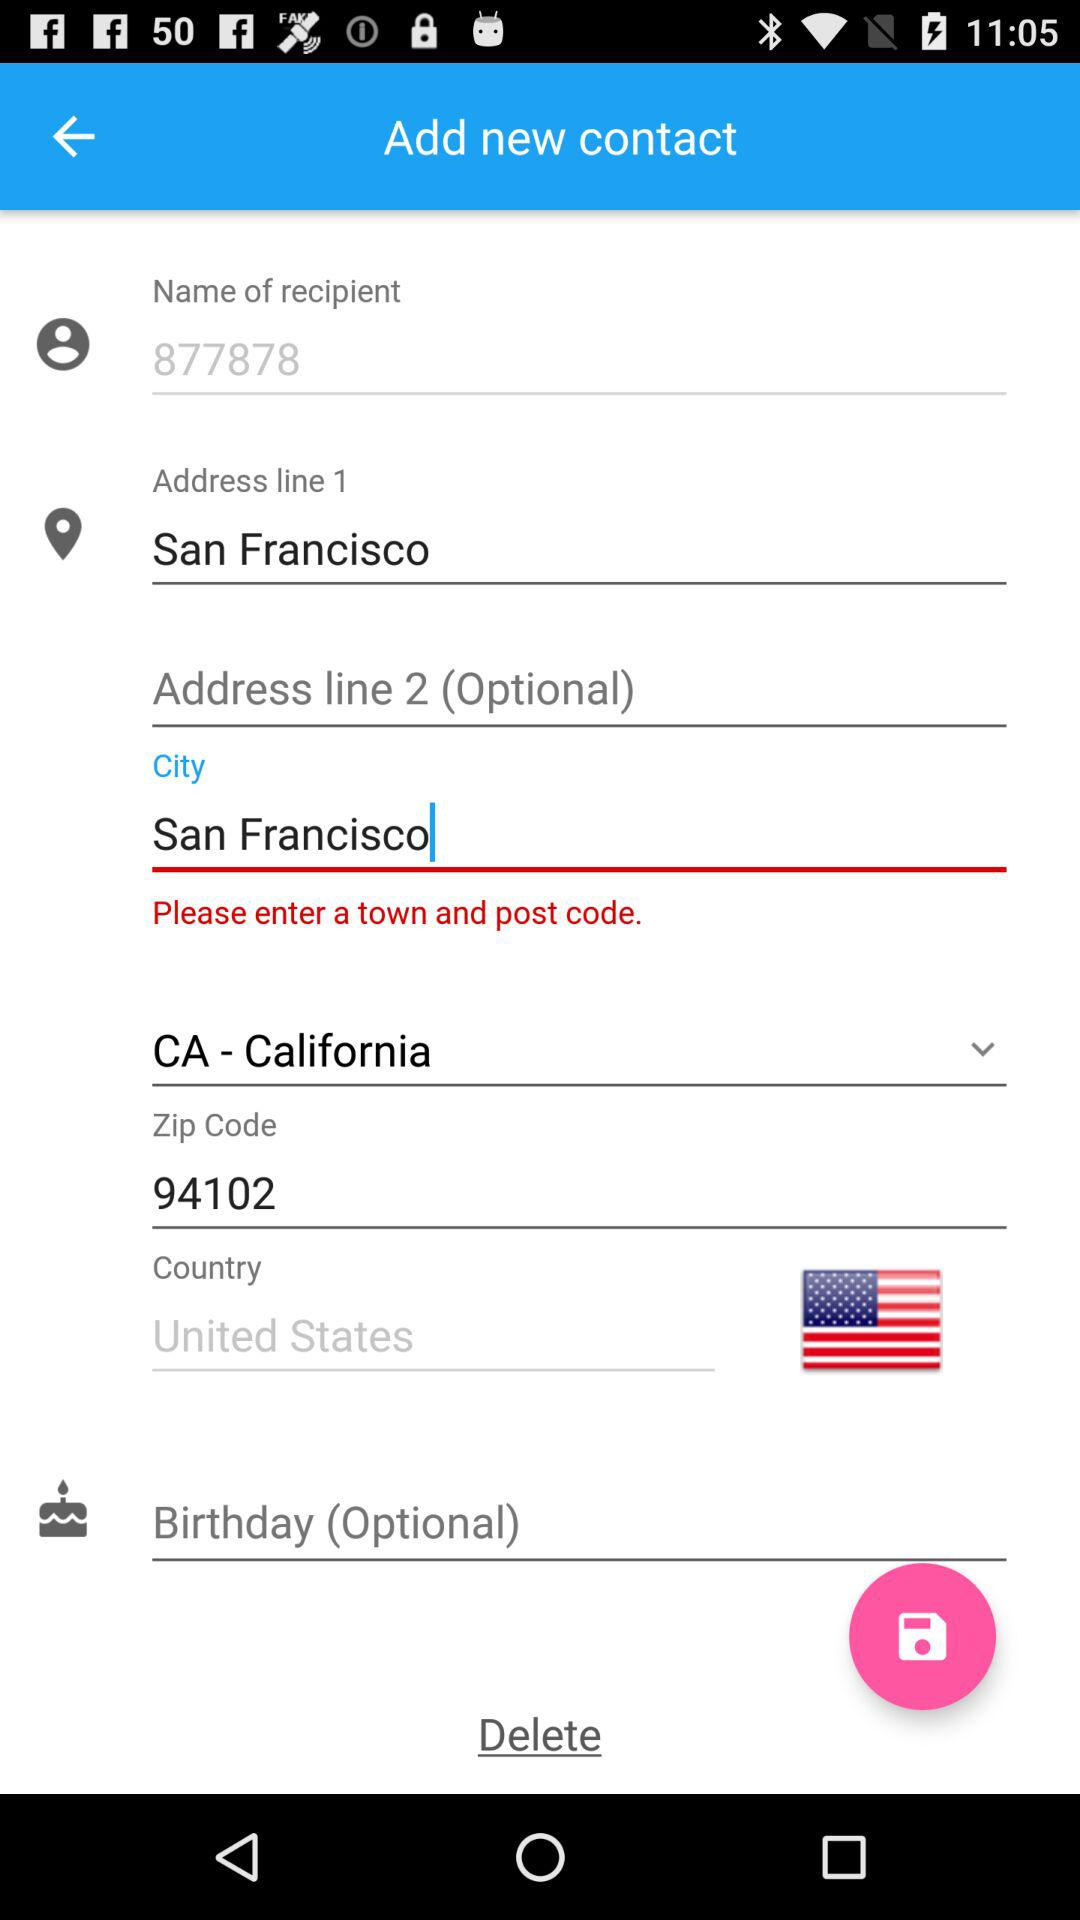What country's flag is shown on the screen? The flag of the United States is shown on the screen. 